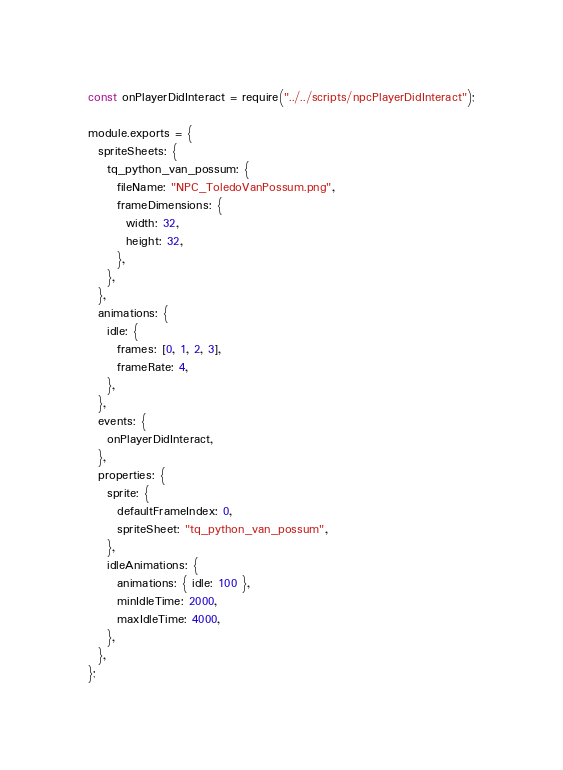Convert code to text. <code><loc_0><loc_0><loc_500><loc_500><_JavaScript_>const onPlayerDidInteract = require("../../scripts/npcPlayerDidInteract");

module.exports = {
  spriteSheets: {
    tq_python_van_possum: {
      fileName: "NPC_ToledoVanPossum.png",
      frameDimensions: {
        width: 32,
        height: 32,
      },
    },
  },
  animations: {
    idle: {
      frames: [0, 1, 2, 3],
      frameRate: 4,
    },
  },
  events: {
    onPlayerDidInteract,
  },
  properties: {
    sprite: {
      defaultFrameIndex: 0,
      spriteSheet: "tq_python_van_possum",
    },
    idleAnimations: {
      animations: { idle: 100 },
      minIdleTime: 2000,
      maxIdleTime: 4000,
    },
  },
};
</code> 